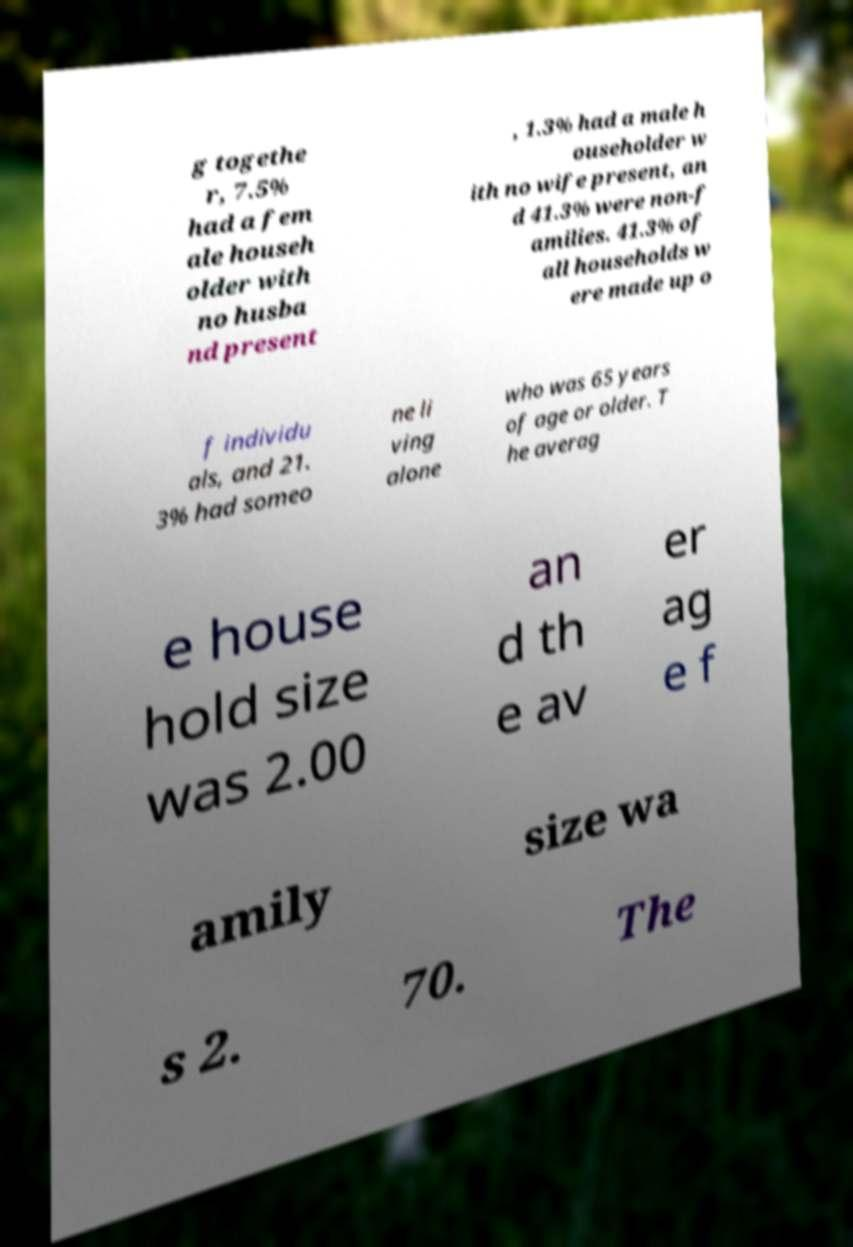Can you read and provide the text displayed in the image?This photo seems to have some interesting text. Can you extract and type it out for me? g togethe r, 7.5% had a fem ale househ older with no husba nd present , 1.3% had a male h ouseholder w ith no wife present, an d 41.3% were non-f amilies. 41.3% of all households w ere made up o f individu als, and 21. 3% had someo ne li ving alone who was 65 years of age or older. T he averag e house hold size was 2.00 an d th e av er ag e f amily size wa s 2. 70. The 